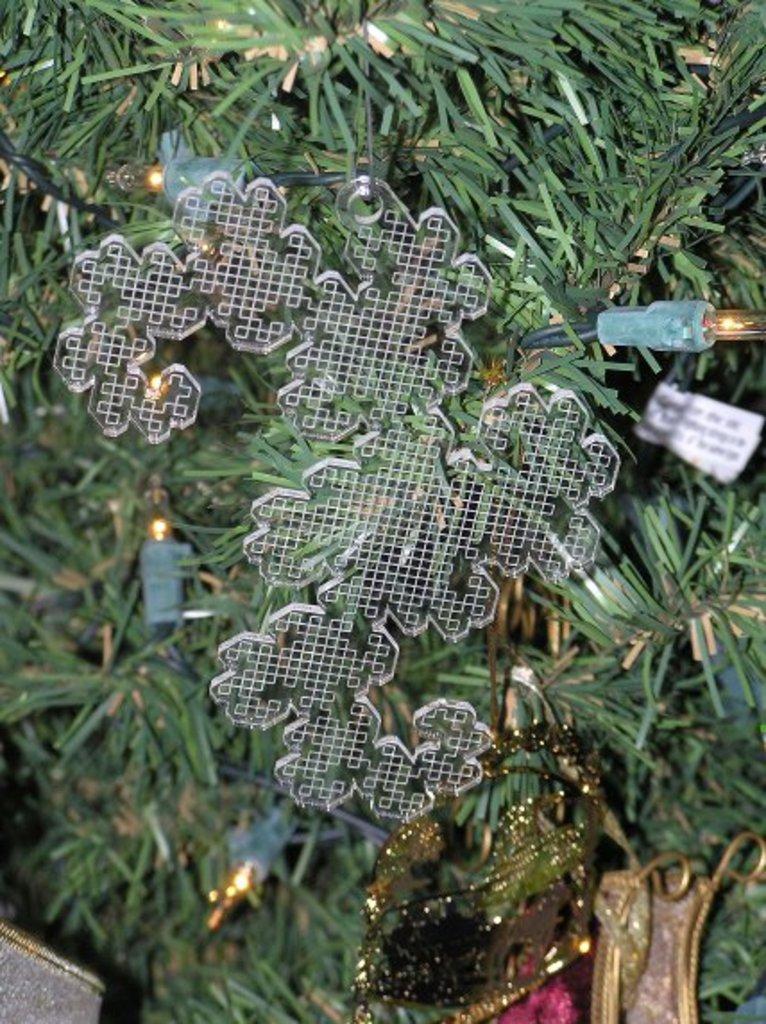How would you summarize this image in a sentence or two? This picture contains Christmas tree. This tree is decorated with lights and something in white color is changed to that tree. At the bottom of the picture, we see gift hanged to that tree. 